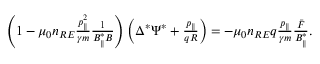Convert formula to latex. <formula><loc_0><loc_0><loc_500><loc_500>\begin{array} { r } { \left ( 1 - \mu _ { 0 } n _ { R E } \frac { p _ { \| } ^ { 2 } } { \gamma m } \frac { 1 } { B _ { \| } ^ { * } B } \right ) \left ( \Delta ^ { * } \Psi ^ { * } + \frac { p _ { \| } } { q R } \right ) = - \mu _ { 0 } n _ { R E } q \frac { p _ { \| } } { \gamma m } \frac { \bar { F } } { B _ { \| } ^ { * } } . } \end{array}</formula> 